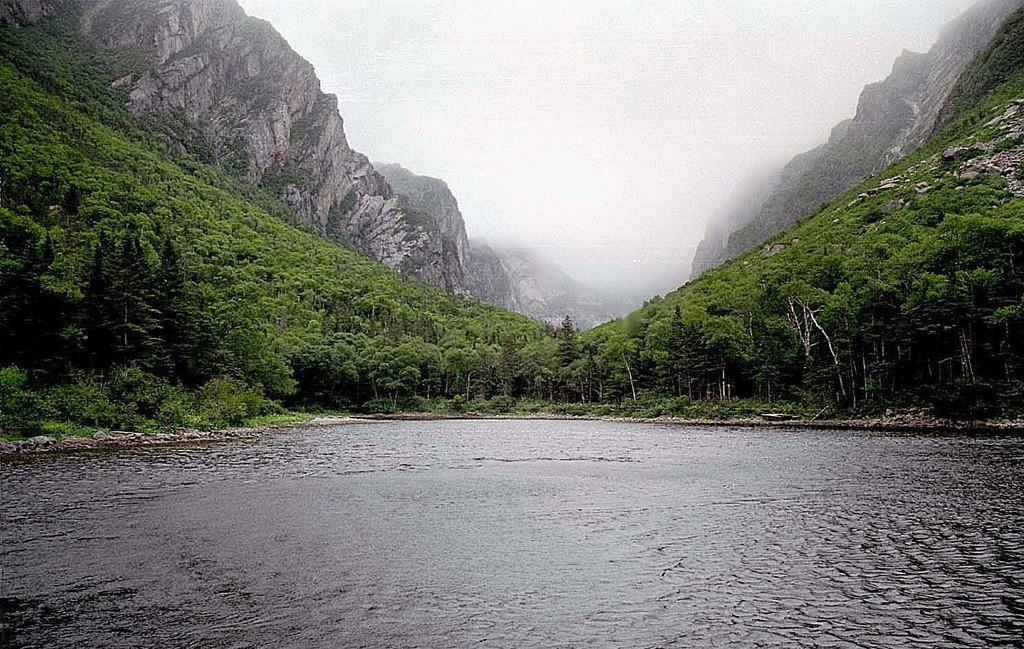Where was the picture taken? The picture was clicked outside. What is in the foreground of the image? There is a water body in the foreground of the image. What can be seen in the background of the image? The sky, hills, trees, plants, and a portion of green grass are visible in the background of the image. How does the water body in the image affect the digestion of the person viewing the image? The water body in the image does not have any direct impact on the digestion of the person viewing the image. 